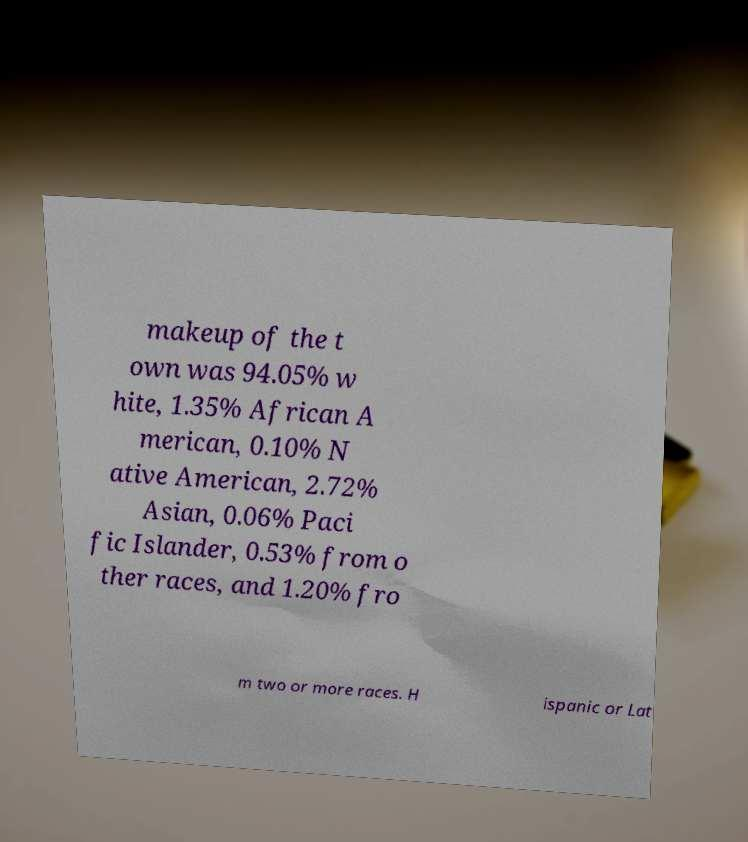Can you accurately transcribe the text from the provided image for me? makeup of the t own was 94.05% w hite, 1.35% African A merican, 0.10% N ative American, 2.72% Asian, 0.06% Paci fic Islander, 0.53% from o ther races, and 1.20% fro m two or more races. H ispanic or Lat 